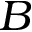<formula> <loc_0><loc_0><loc_500><loc_500>B</formula> 